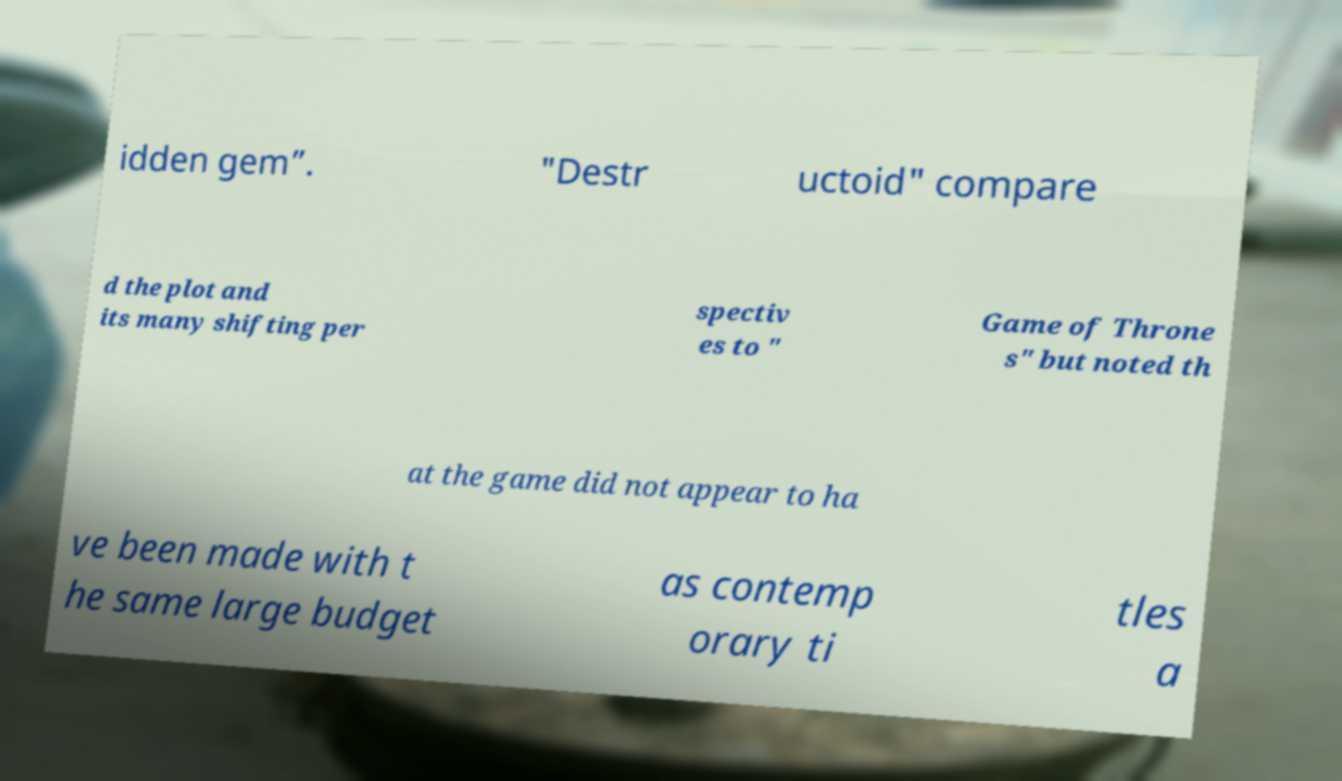Could you assist in decoding the text presented in this image and type it out clearly? idden gem”. "Destr uctoid" compare d the plot and its many shifting per spectiv es to " Game of Throne s" but noted th at the game did not appear to ha ve been made with t he same large budget as contemp orary ti tles a 